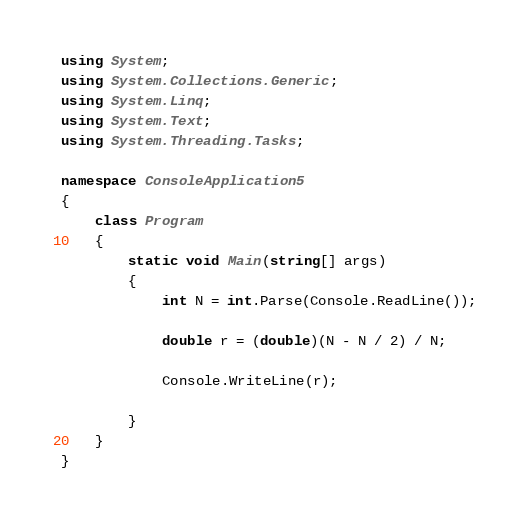<code> <loc_0><loc_0><loc_500><loc_500><_C#_>using System;
using System.Collections.Generic;
using System.Linq;
using System.Text;
using System.Threading.Tasks;

namespace ConsoleApplication5
{
    class Program
    {
        static void Main(string[] args)
        {
            int N = int.Parse(Console.ReadLine());

            double r = (double)(N - N / 2) / N;

            Console.WriteLine(r);

        }
    }
}
</code> 